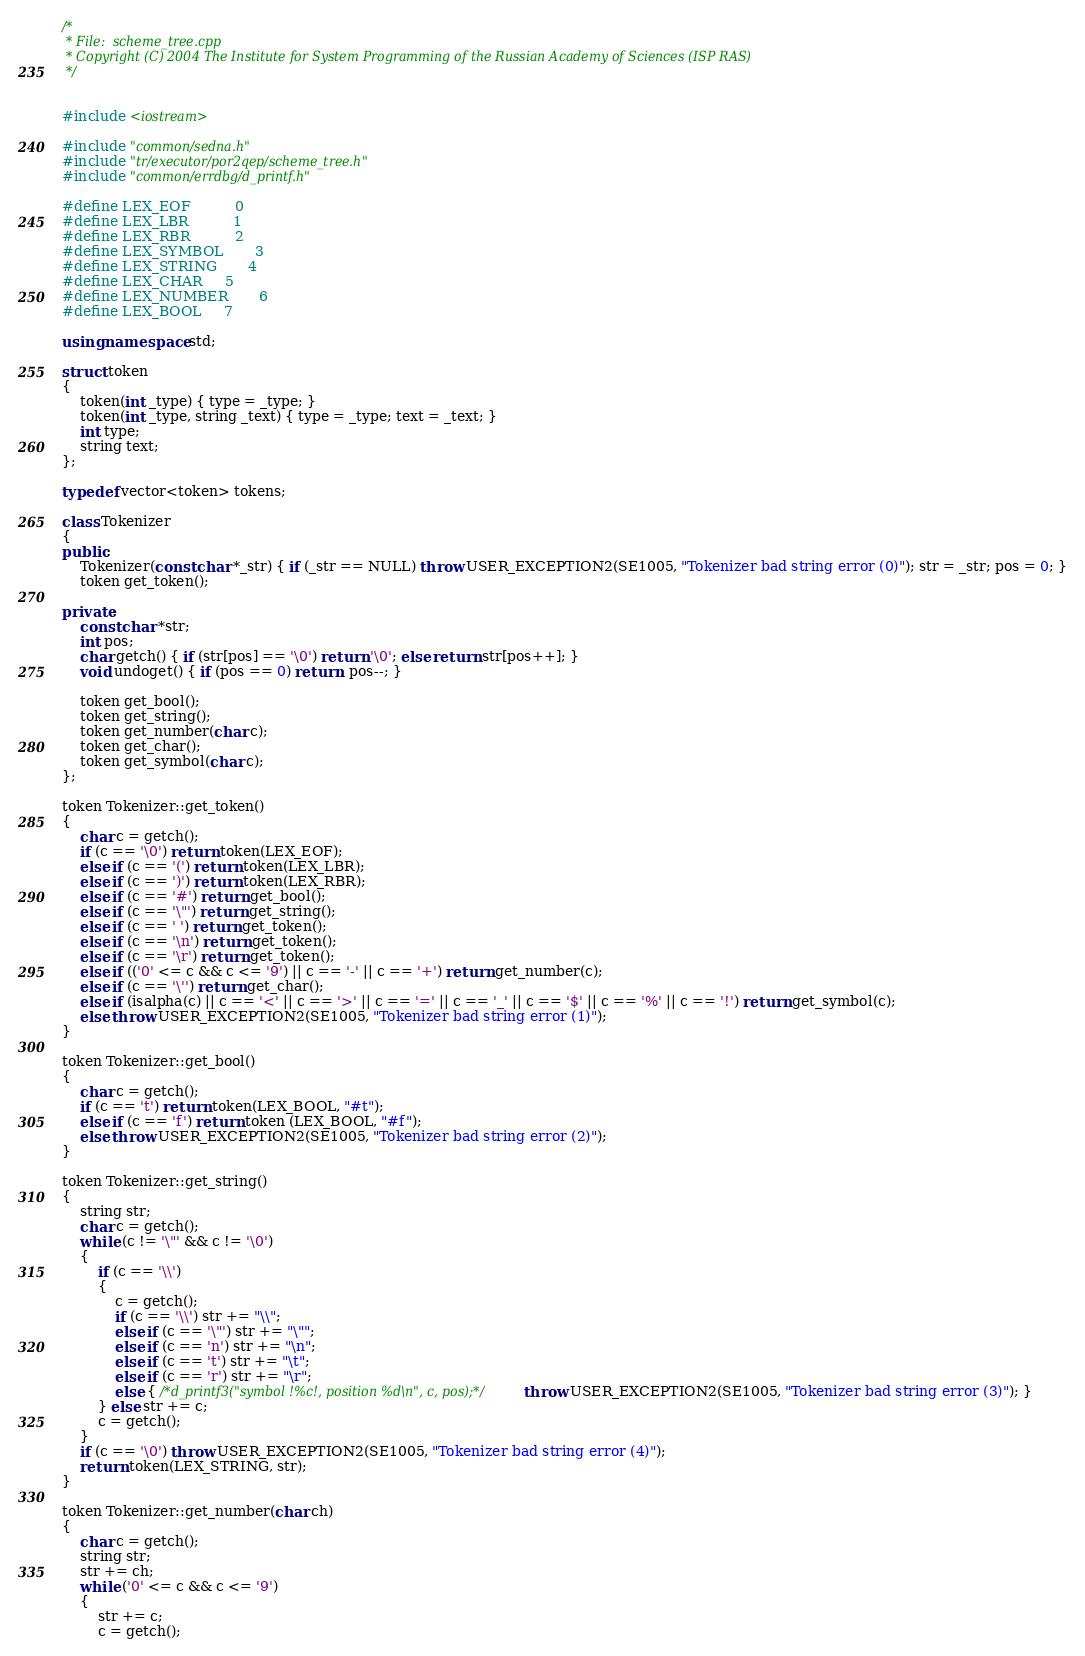Convert code to text. <code><loc_0><loc_0><loc_500><loc_500><_C++_>/*
 * File:  scheme_tree.cpp
 * Copyright (C) 2004 The Institute for System Programming of the Russian Academy of Sciences (ISP RAS)
 */


#include <iostream>

#include "common/sedna.h"
#include "tr/executor/por2qep/scheme_tree.h"
#include "common/errdbg/d_printf.h"

#define LEX_EOF			0
#define LEX_LBR			1
#define LEX_RBR			2
#define LEX_SYMBOL		3
#define LEX_STRING		4
#define LEX_CHAR		5
#define LEX_NUMBER		6
#define LEX_BOOL		7

using namespace std;

struct token
{
    token(int _type) { type = _type; }
    token(int _type, string _text) { type = _type; text = _text; }
    int type;
    string text;
};

typedef vector<token> tokens;

class Tokenizer
{
public:
    Tokenizer(const char *_str) { if (_str == NULL) throw USER_EXCEPTION2(SE1005, "Tokenizer bad string error (0)"); str = _str; pos = 0; }
    token get_token();

private:
    const char *str;
    int pos;
    char getch() { if (str[pos] == '\0') return '\0'; else return str[pos++]; } 
    void undoget() { if (pos == 0) return; pos--; }

    token get_bool();
    token get_string();
    token get_number(char c);
    token get_char();
    token get_symbol(char c);
};

token Tokenizer::get_token()
{
    char c = getch();
    if (c == '\0') return token(LEX_EOF);
    else if (c == '(') return token(LEX_LBR);
    else if (c == ')') return token(LEX_RBR);
    else if (c == '#') return get_bool();
    else if (c == '\"') return get_string();
    else if (c == ' ') return get_token();
	else if (c == '\n') return get_token();
	else if (c == '\r') return get_token();
    else if (('0' <= c && c <= '9') || c == '-' || c == '+') return get_number(c);
    else if (c == '\'') return get_char();
    else if (isalpha(c) || c == '<' || c == '>' || c == '=' || c == '_' || c == '$' || c == '%' || c == '!') return get_symbol(c);
    else throw USER_EXCEPTION2(SE1005, "Tokenizer bad string error (1)");
}

token Tokenizer::get_bool()
{
    char c = getch();
    if (c == 't') return token(LEX_BOOL, "#t");
    else if (c == 'f') return token (LEX_BOOL, "#f");
    else throw USER_EXCEPTION2(SE1005, "Tokenizer bad string error (2)");
}

token Tokenizer::get_string()
{
    string str;
    char c = getch();
    while (c != '\"' && c != '\0')
    {
        if (c == '\\')
        {
            c = getch();
            if (c == '\\') str += "\\";
            else if (c == '\"') str += "\"";
            else if (c == 'n') str += "\n";
            else if (c == 't') str += "\t";
            else if (c == 'r') str += "\r";
            else { /*d_printf3("symbol !%c!, position %d\n", c, pos);*/ throw USER_EXCEPTION2(SE1005, "Tokenizer bad string error (3)"); }
        } else str += c;
        c = getch();
    }
    if (c == '\0') throw USER_EXCEPTION2(SE1005, "Tokenizer bad string error (4)");
    return token(LEX_STRING, str);
}

token Tokenizer::get_number(char ch)
{
    char c = getch();
    string str;
    str += ch;
    while ('0' <= c && c <= '9')
    {
        str += c;
        c = getch();</code> 